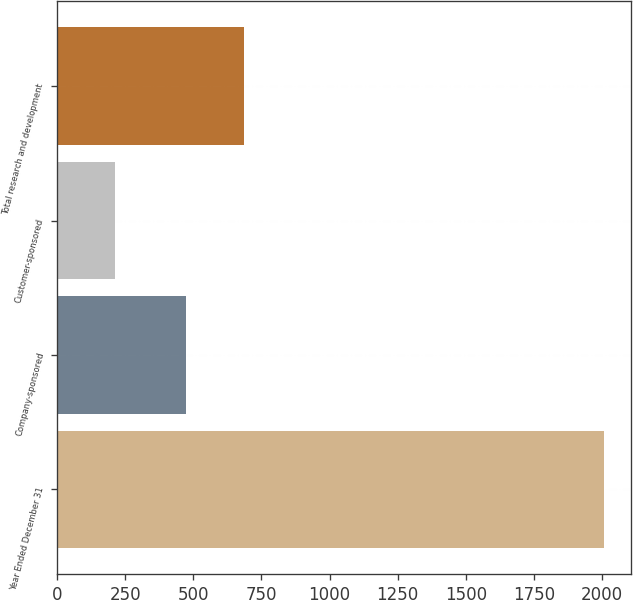Convert chart. <chart><loc_0><loc_0><loc_500><loc_500><bar_chart><fcel>Year Ended December 31<fcel>Company-sponsored<fcel>Customer-sponsored<fcel>Total research and development<nl><fcel>2008<fcel>474<fcel>212<fcel>686<nl></chart> 